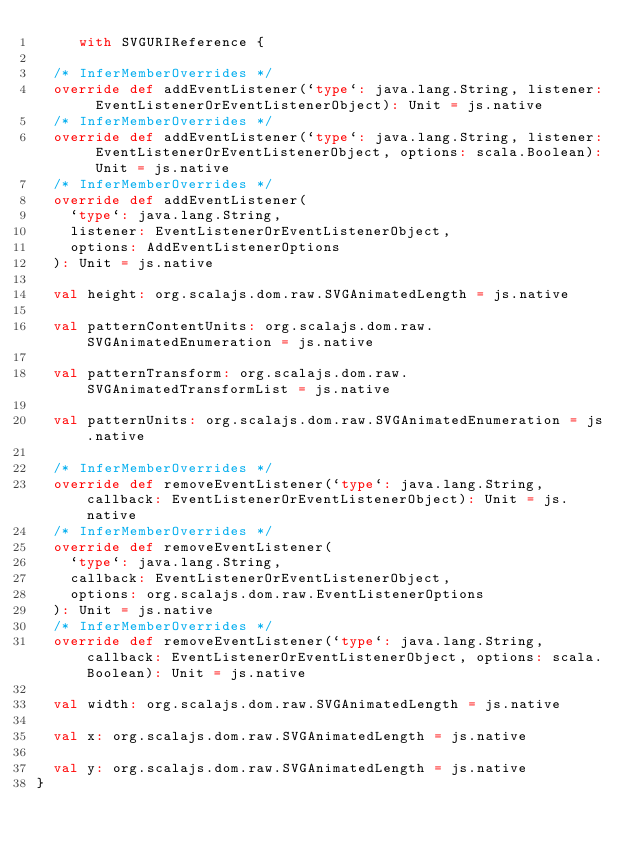Convert code to text. <code><loc_0><loc_0><loc_500><loc_500><_Scala_>     with SVGURIReference {
  
  /* InferMemberOverrides */
  override def addEventListener(`type`: java.lang.String, listener: EventListenerOrEventListenerObject): Unit = js.native
  /* InferMemberOverrides */
  override def addEventListener(`type`: java.lang.String, listener: EventListenerOrEventListenerObject, options: scala.Boolean): Unit = js.native
  /* InferMemberOverrides */
  override def addEventListener(
    `type`: java.lang.String,
    listener: EventListenerOrEventListenerObject,
    options: AddEventListenerOptions
  ): Unit = js.native
  
  val height: org.scalajs.dom.raw.SVGAnimatedLength = js.native
  
  val patternContentUnits: org.scalajs.dom.raw.SVGAnimatedEnumeration = js.native
  
  val patternTransform: org.scalajs.dom.raw.SVGAnimatedTransformList = js.native
  
  val patternUnits: org.scalajs.dom.raw.SVGAnimatedEnumeration = js.native
  
  /* InferMemberOverrides */
  override def removeEventListener(`type`: java.lang.String, callback: EventListenerOrEventListenerObject): Unit = js.native
  /* InferMemberOverrides */
  override def removeEventListener(
    `type`: java.lang.String,
    callback: EventListenerOrEventListenerObject,
    options: org.scalajs.dom.raw.EventListenerOptions
  ): Unit = js.native
  /* InferMemberOverrides */
  override def removeEventListener(`type`: java.lang.String, callback: EventListenerOrEventListenerObject, options: scala.Boolean): Unit = js.native
  
  val width: org.scalajs.dom.raw.SVGAnimatedLength = js.native
  
  val x: org.scalajs.dom.raw.SVGAnimatedLength = js.native
  
  val y: org.scalajs.dom.raw.SVGAnimatedLength = js.native
}
</code> 